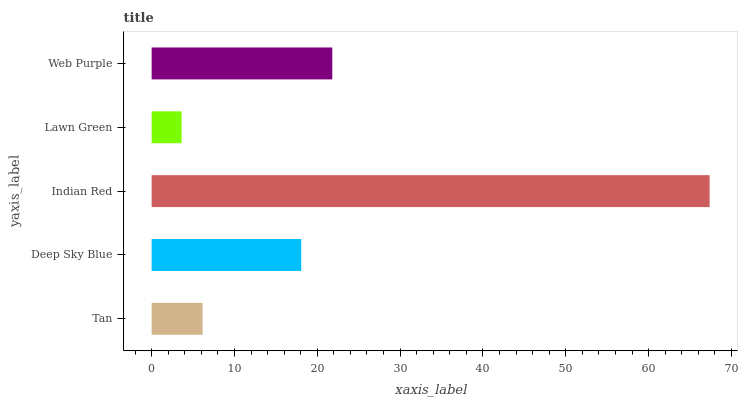Is Lawn Green the minimum?
Answer yes or no. Yes. Is Indian Red the maximum?
Answer yes or no. Yes. Is Deep Sky Blue the minimum?
Answer yes or no. No. Is Deep Sky Blue the maximum?
Answer yes or no. No. Is Deep Sky Blue greater than Tan?
Answer yes or no. Yes. Is Tan less than Deep Sky Blue?
Answer yes or no. Yes. Is Tan greater than Deep Sky Blue?
Answer yes or no. No. Is Deep Sky Blue less than Tan?
Answer yes or no. No. Is Deep Sky Blue the high median?
Answer yes or no. Yes. Is Deep Sky Blue the low median?
Answer yes or no. Yes. Is Tan the high median?
Answer yes or no. No. Is Indian Red the low median?
Answer yes or no. No. 